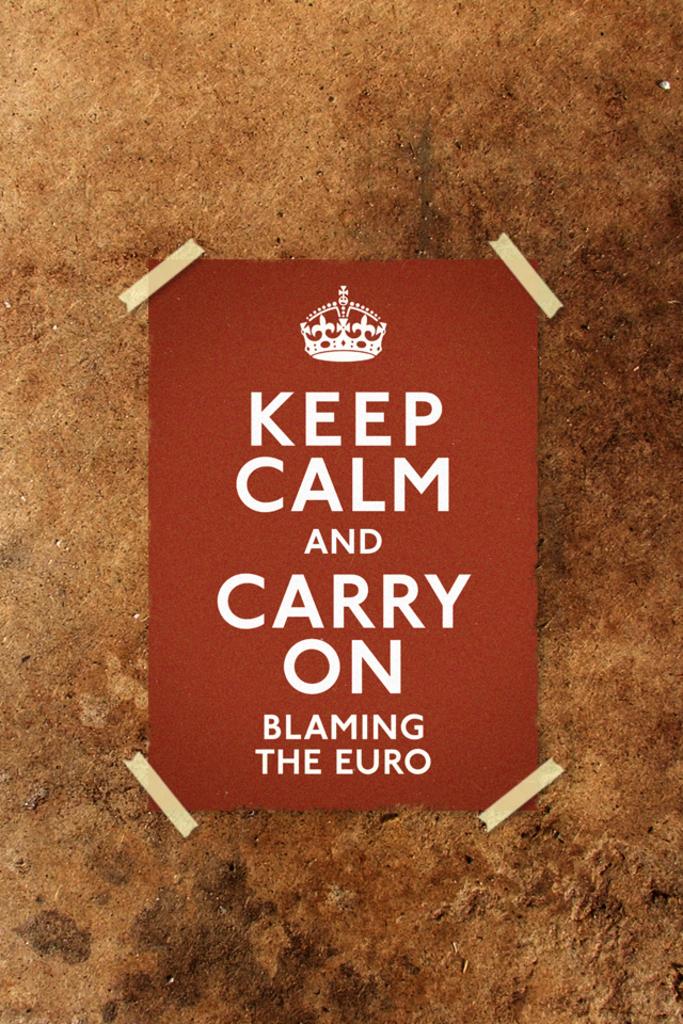Keep calm and do what?
Offer a very short reply. Carry on blaming the euro. What should you blame?
Give a very brief answer. The euro. 